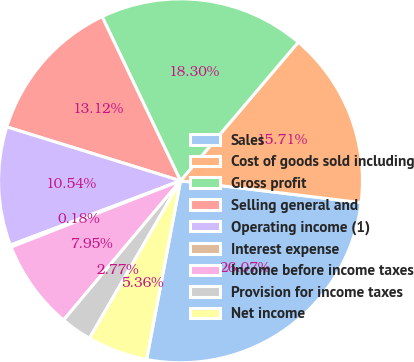<chart> <loc_0><loc_0><loc_500><loc_500><pie_chart><fcel>Sales<fcel>Cost of goods sold including<fcel>Gross profit<fcel>Selling general and<fcel>Operating income (1)<fcel>Interest expense<fcel>Income before income taxes<fcel>Provision for income taxes<fcel>Net income<nl><fcel>26.07%<fcel>15.71%<fcel>18.3%<fcel>13.12%<fcel>10.54%<fcel>0.18%<fcel>7.95%<fcel>2.77%<fcel>5.36%<nl></chart> 